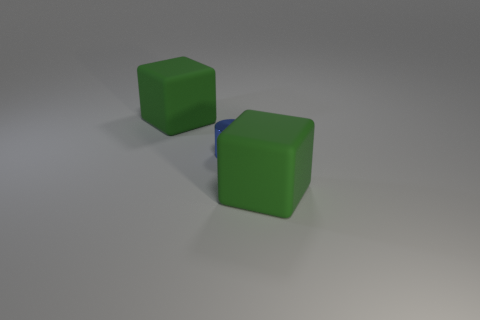Add 2 large purple metallic cubes. How many objects exist? 5 Subtract all cylinders. How many objects are left? 2 Add 1 tiny blue objects. How many tiny blue objects are left? 2 Add 2 tiny blue things. How many tiny blue things exist? 3 Subtract 0 yellow cylinders. How many objects are left? 3 Subtract all blue cylinders. Subtract all blue things. How many objects are left? 1 